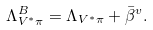Convert formula to latex. <formula><loc_0><loc_0><loc_500><loc_500>\Lambda ^ { B } _ { V ^ { * } \pi } = \Lambda _ { V ^ { * } \pi } + \bar { \beta } ^ { v } .</formula> 